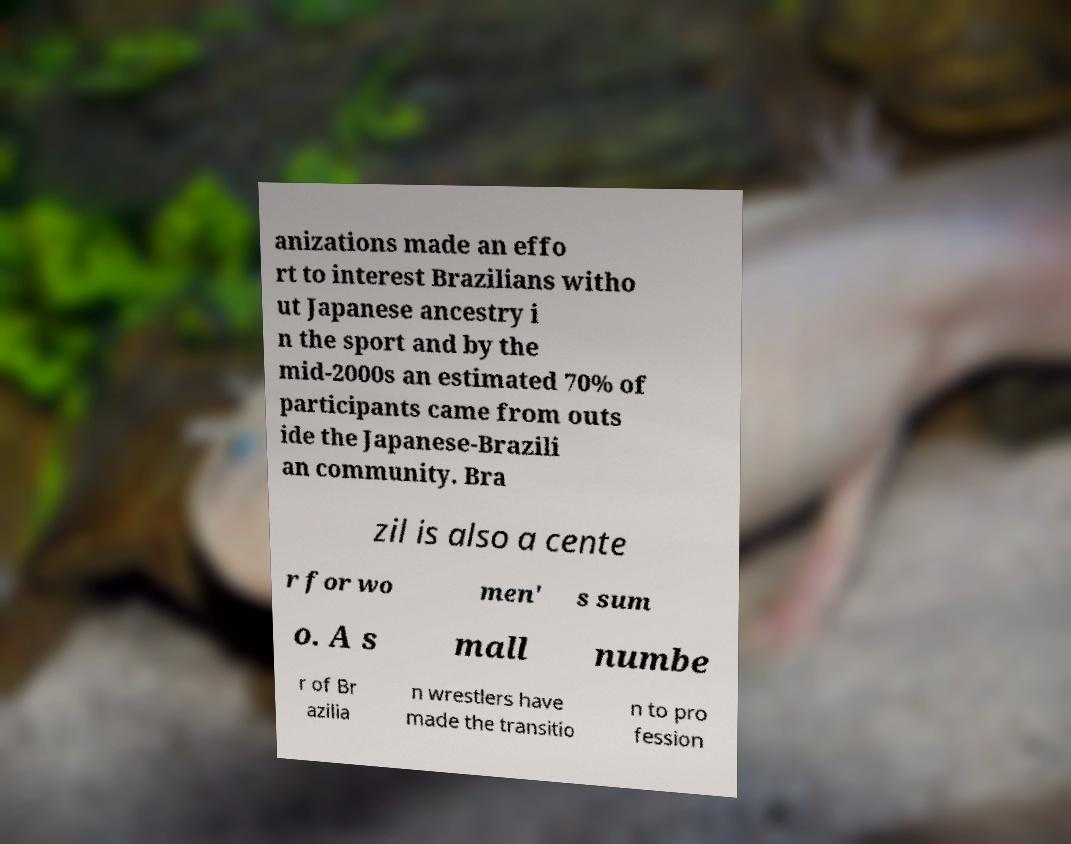What messages or text are displayed in this image? I need them in a readable, typed format. anizations made an effo rt to interest Brazilians witho ut Japanese ancestry i n the sport and by the mid-2000s an estimated 70% of participants came from outs ide the Japanese-Brazili an community. Bra zil is also a cente r for wo men' s sum o. A s mall numbe r of Br azilia n wrestlers have made the transitio n to pro fession 